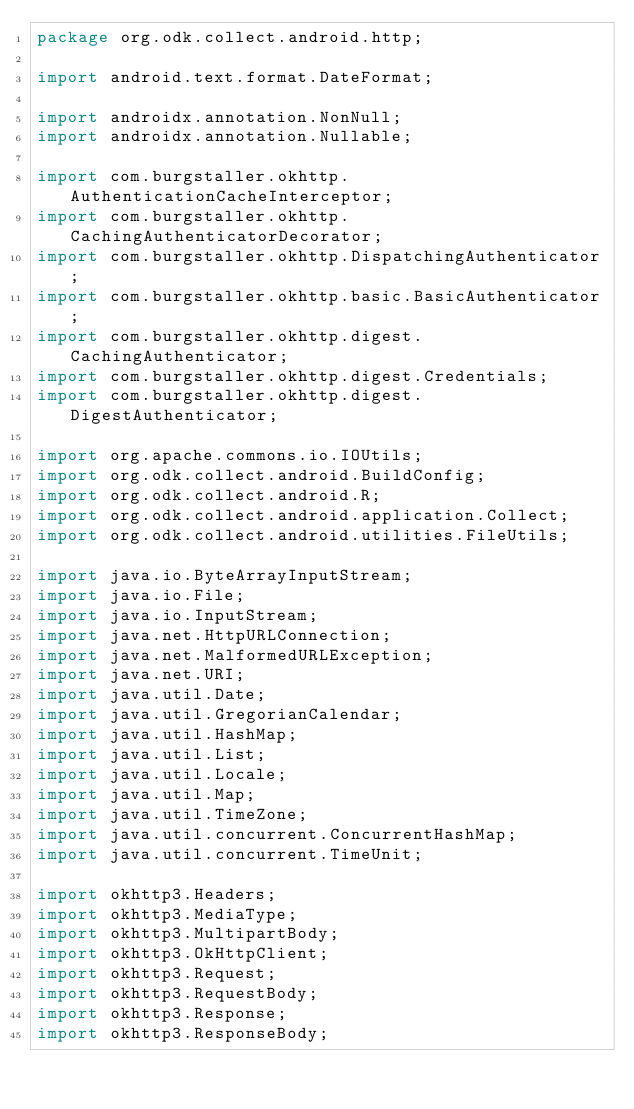<code> <loc_0><loc_0><loc_500><loc_500><_Java_>package org.odk.collect.android.http;

import android.text.format.DateFormat;

import androidx.annotation.NonNull;
import androidx.annotation.Nullable;

import com.burgstaller.okhttp.AuthenticationCacheInterceptor;
import com.burgstaller.okhttp.CachingAuthenticatorDecorator;
import com.burgstaller.okhttp.DispatchingAuthenticator;
import com.burgstaller.okhttp.basic.BasicAuthenticator;
import com.burgstaller.okhttp.digest.CachingAuthenticator;
import com.burgstaller.okhttp.digest.Credentials;
import com.burgstaller.okhttp.digest.DigestAuthenticator;

import org.apache.commons.io.IOUtils;
import org.odk.collect.android.BuildConfig;
import org.odk.collect.android.R;
import org.odk.collect.android.application.Collect;
import org.odk.collect.android.utilities.FileUtils;

import java.io.ByteArrayInputStream;
import java.io.File;
import java.io.InputStream;
import java.net.HttpURLConnection;
import java.net.MalformedURLException;
import java.net.URI;
import java.util.Date;
import java.util.GregorianCalendar;
import java.util.HashMap;
import java.util.List;
import java.util.Locale;
import java.util.Map;
import java.util.TimeZone;
import java.util.concurrent.ConcurrentHashMap;
import java.util.concurrent.TimeUnit;

import okhttp3.Headers;
import okhttp3.MediaType;
import okhttp3.MultipartBody;
import okhttp3.OkHttpClient;
import okhttp3.Request;
import okhttp3.RequestBody;
import okhttp3.Response;
import okhttp3.ResponseBody;</code> 